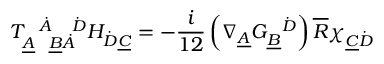<formula> <loc_0><loc_0><loc_500><loc_500>T _ { \underline { A } \quad u n d e r l i n e { B } \dot { A } } ^ { \quad d o t { A } \quad d o t { D } } H _ { \dot { D } \underline { C } } = - \frac { i } { 1 2 } \left ( \nabla _ { \underline { A } } G _ { \underline { B } } ^ { \quad d o t { D } } \right ) \overline { R } \chi _ { \underline { C } \dot { D } }</formula> 